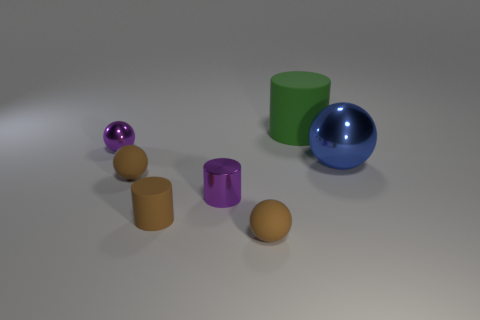Is there a ball that has the same material as the large cylinder?
Your answer should be very brief. Yes. What is the size of the shiny sphere that is the same color as the tiny metal cylinder?
Your answer should be very brief. Small. How many purple things are either big metal balls or tiny rubber objects?
Offer a very short reply. 0. Are there any tiny metallic things that have the same color as the metal cylinder?
Offer a terse response. Yes. What is the size of the other sphere that is made of the same material as the large blue ball?
Offer a terse response. Small. How many blocks are either tiny matte objects or big things?
Offer a very short reply. 0. Is the number of purple balls greater than the number of large metallic cylinders?
Offer a very short reply. Yes. How many other brown cylinders have the same size as the brown matte cylinder?
Give a very brief answer. 0. There is a small thing that is the same color as the small metallic cylinder; what is its shape?
Provide a short and direct response. Sphere. What number of things are either rubber cylinders in front of the green cylinder or tiny brown rubber cylinders?
Offer a terse response. 1. 